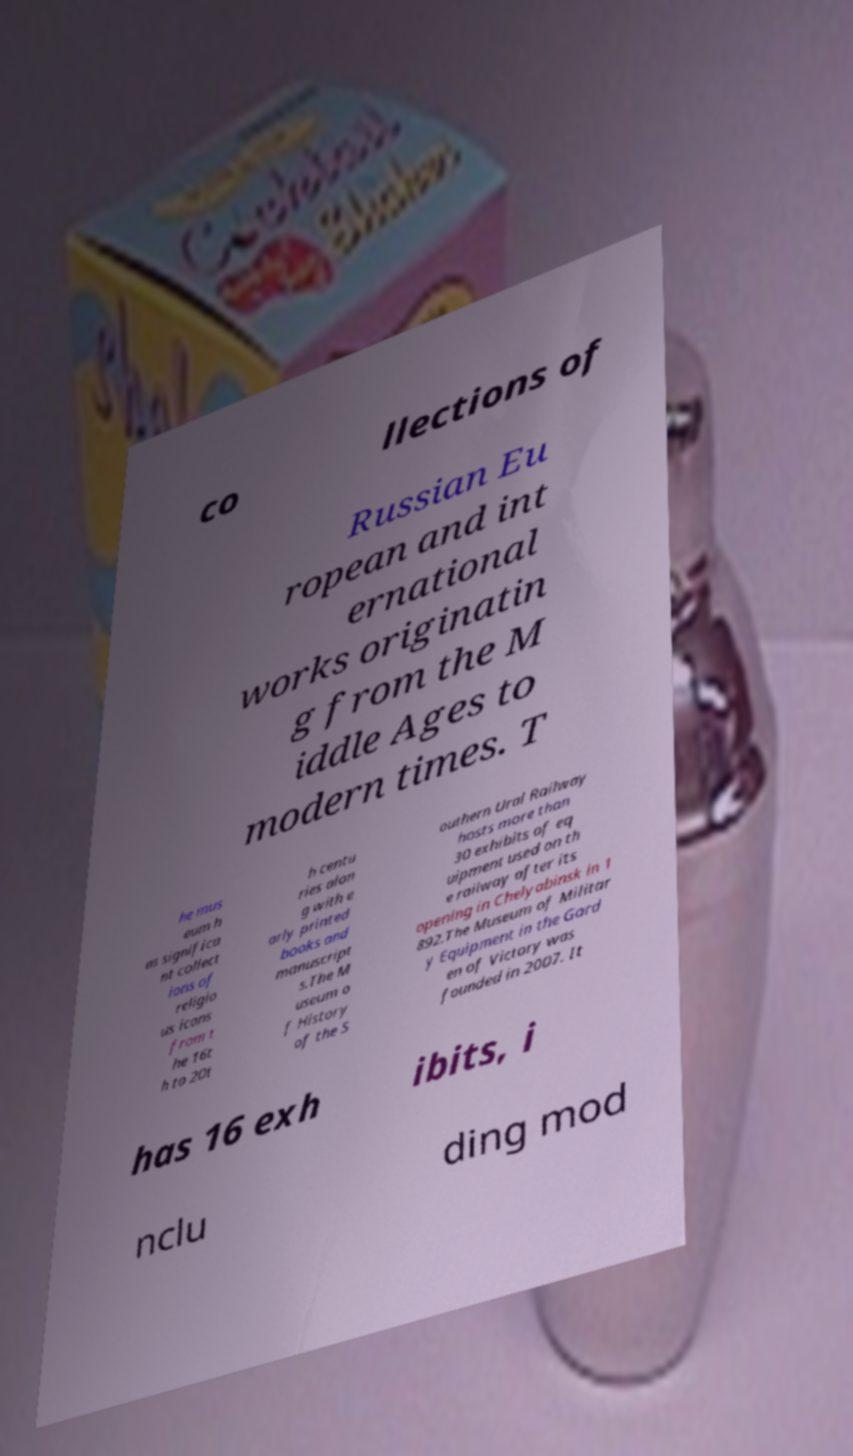Can you accurately transcribe the text from the provided image for me? co llections of Russian Eu ropean and int ernational works originatin g from the M iddle Ages to modern times. T he mus eum h as significa nt collect ions of religio us icons from t he 16t h to 20t h centu ries alon g with e arly printed books and manuscript s.The M useum o f History of the S outhern Ural Railway hosts more than 30 exhibits of eq uipment used on th e railway after its opening in Chelyabinsk in 1 892.The Museum of Militar y Equipment in the Gard en of Victory was founded in 2007. It has 16 exh ibits, i nclu ding mod 